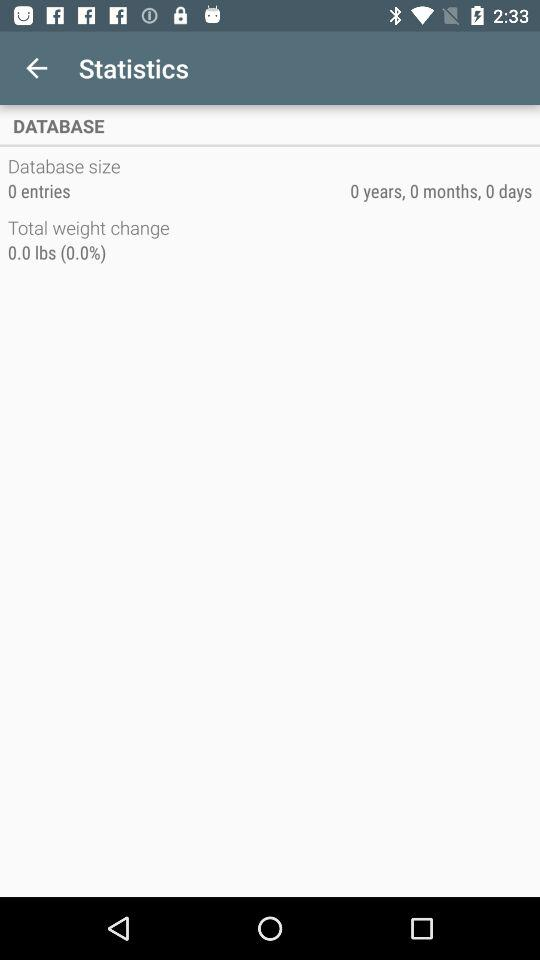What is the application name?
When the provided information is insufficient, respond with <no answer>. <no answer> 